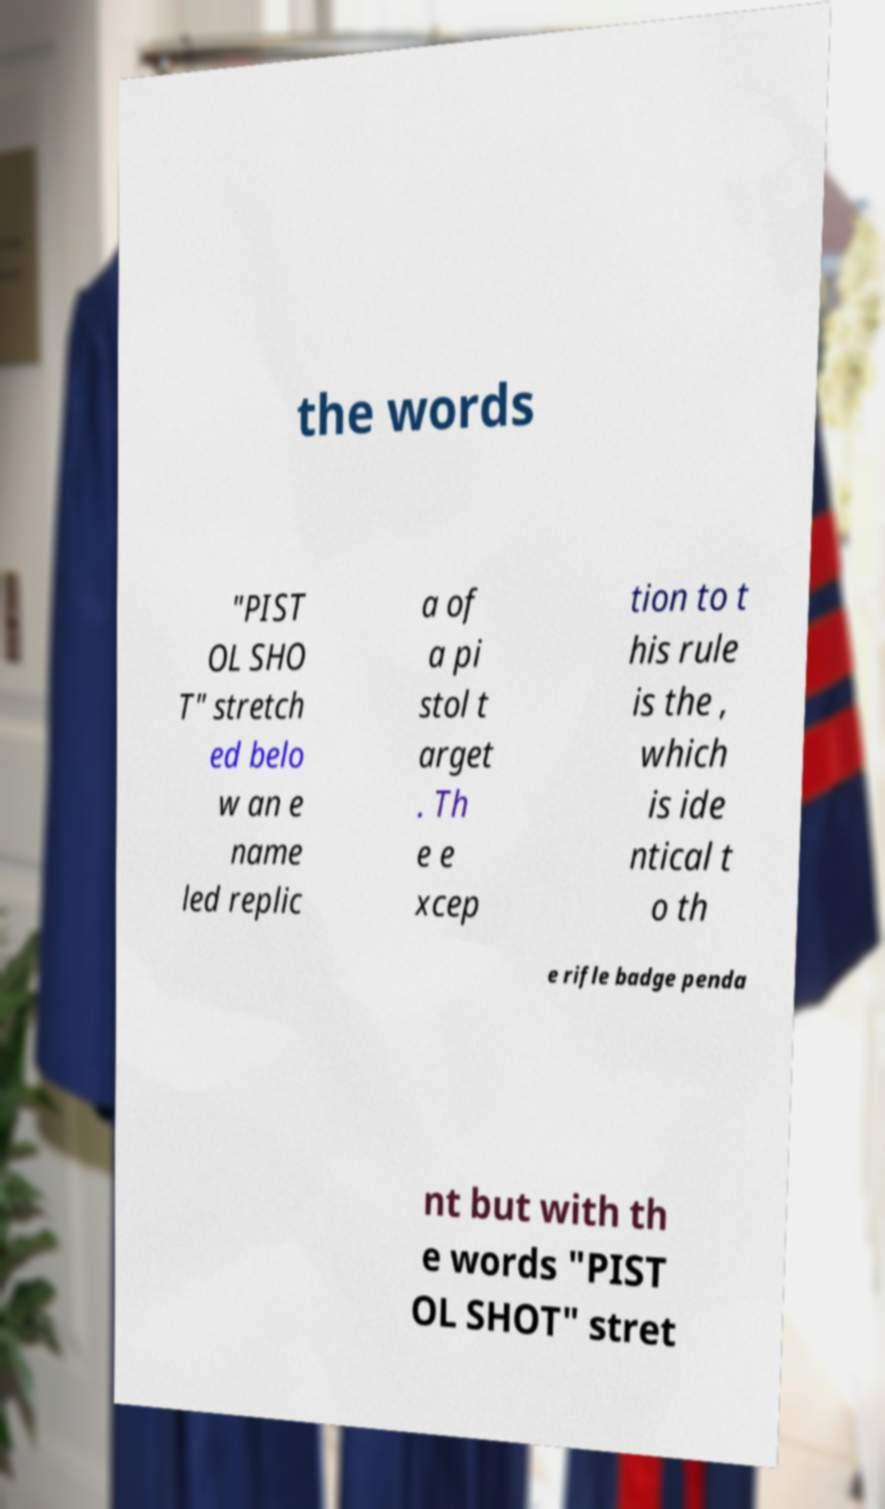There's text embedded in this image that I need extracted. Can you transcribe it verbatim? the words "PIST OL SHO T" stretch ed belo w an e name led replic a of a pi stol t arget . Th e e xcep tion to t his rule is the , which is ide ntical t o th e rifle badge penda nt but with th e words "PIST OL SHOT" stret 